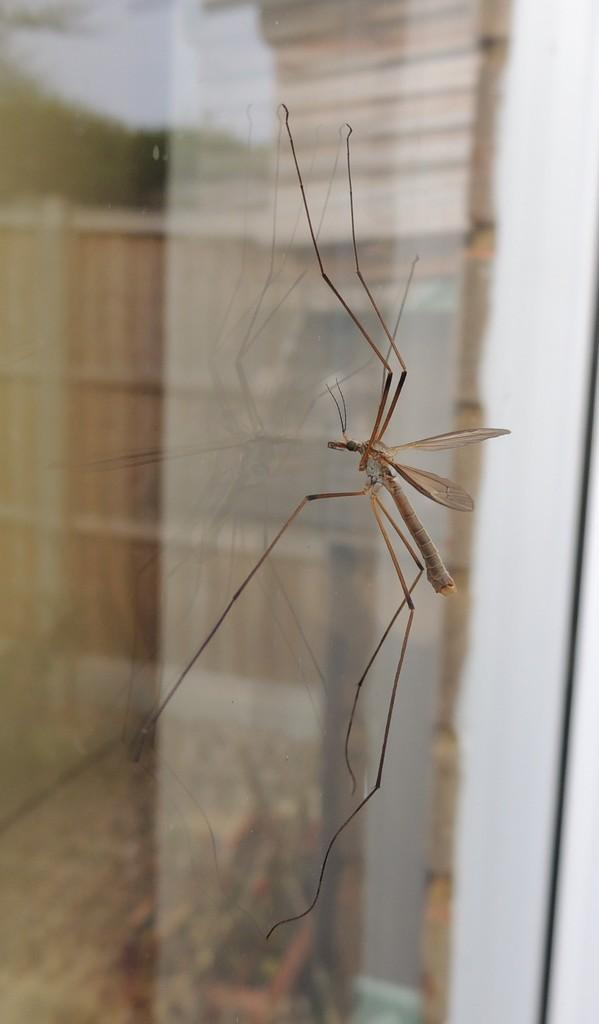What is on the glass in the image? There is an insect on the glass in the image. Can you describe the background of the image? The background of the image is blurry. What type of rhythm can be heard from the goat in the image? There is no goat present in the image, so it is not possible to determine any rhythm associated with it. 